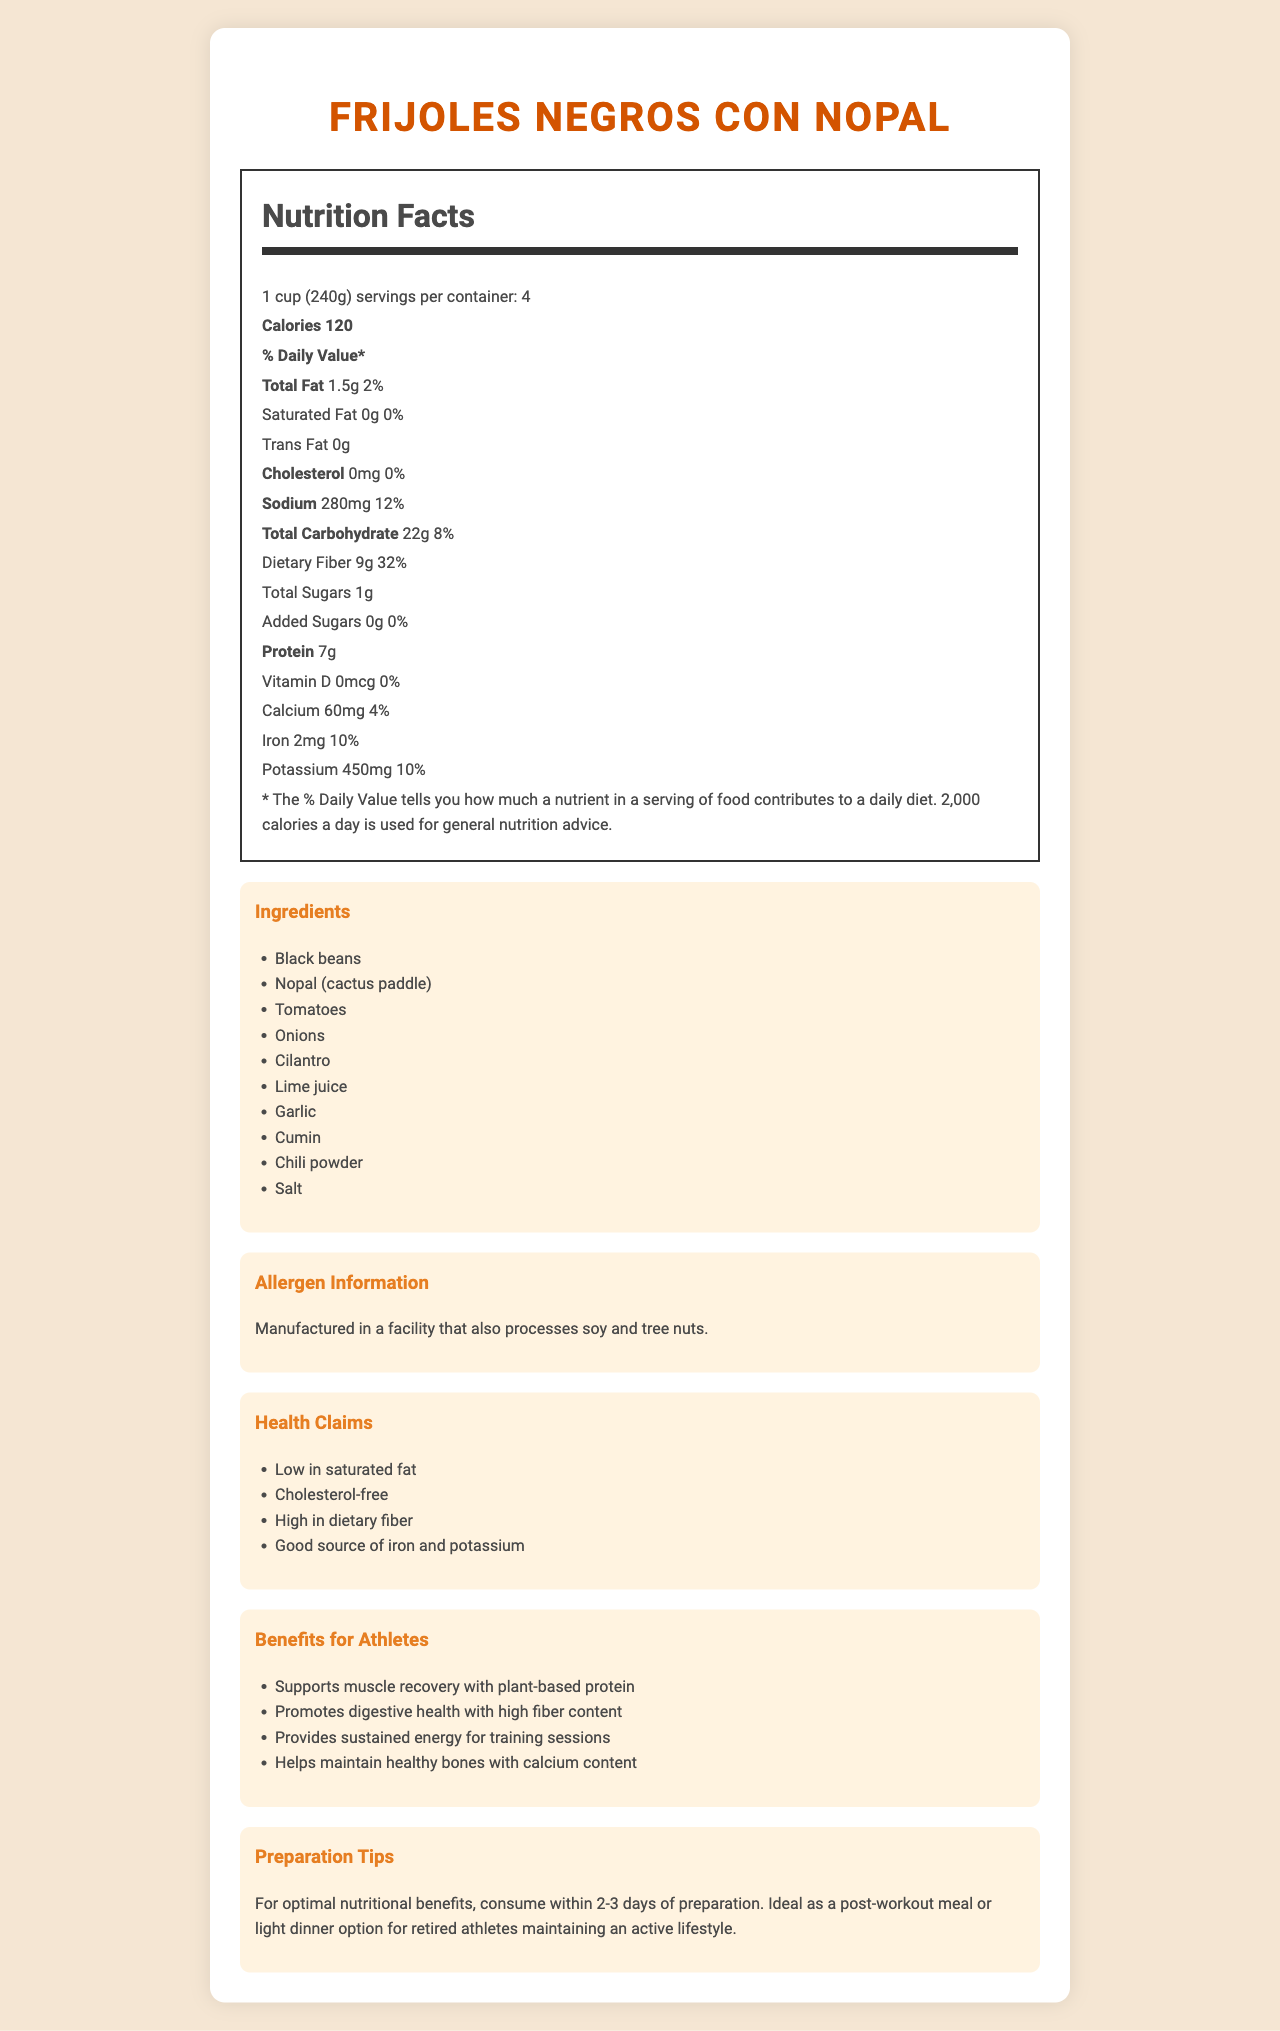what is the name of the product? The name of the product is displayed at the top of the document.
Answer: Frijoles Negros con Nopal what is the serving size of this dish? The serving size is mentioned in the nutrition label section of the document.
Answer: 1 cup (240g) how many servings are there per container? The number of servings per container is displayed under the nutrition facts section.
Answer: 4 what is the total calorie content per serving? The calorie content per serving is listed in the nutrition facts section.
Answer: 120 how much dietary fiber does one serving contain? The dietary fiber content per serving is provided in the nutrition facts under "Total Carbohydrate".
Answer: 9g what is the daily value percentage of iron? The daily value percentage of iron is listed in the nutrition facts section.
Answer: 10% are there any added sugars in this product? The document states "Added Sugars 0g 0%", indicating no added sugars.
Answer: No does this product contain cholesterol? The document indicates "Cholesterol 0mg 0%", meaning it is cholesterol-free.
Answer: No how much sodium does one serving contain? The sodium content per serving is displayed in the nutrition facts section.
Answer: 280mg what are the main ingredients in this dish? The main ingredients are listed under the ingredients section.
Answer: Black beans, Nopal (cactus paddle), Tomatoes, Onions, Cilantro, Lime juice, Garlic, Cumin, Chili powder, Salt how can this dish benefit retired athletes? A. Helps with muscle recovery B. Promotes digestive health C. Provides sustained energy D. All of the above The athlete benefits section lists all these benefits for retired athletes.
Answer: D. All of the above which health claim is NOT made about this product? I. Low in saturated fat II. High in protein III. Good source of iron The document does not mention "High in protein" as part of the health claims.
Answer: II. High in protein is this product manufactured in a facility that processes soy and tree nuts? The allergen information section confirms this.
Answer: Yes describe the main nutritional benefits of this dish. The nutrition facts and health claims sections highlight these benefits.
Answer: This dish is low in calories and saturated fat, contains no cholesterol, and provides a high amount of dietary fiber. It is also a good source of iron and potassium. what is the recommended consumption time for optimal nutritional benefits? The preparation tips section recommends consuming within 2-3 days of preparation for optimal nutritional benefits.
Answer: 2-3 days of preparation does this dish provide any vitamin D? The nutrition facts section indicates "Vitamin D 0mcg 0%".
Answer: No how many grams of total carbohydrates are there per serving? The total carbohydrate content per serving is listed in the nutrition facts section.
Answer: 22g can the specific facilities where this product is manufactured be identified with the given information? The document states allergen information but does not specify the facilities where the product is manufactured.
Answer: Not enough information 